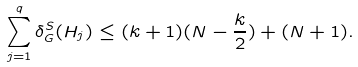<formula> <loc_0><loc_0><loc_500><loc_500>\sum _ { j = 1 } ^ { q } \delta ^ { S } _ { G } ( H _ { j } ) \leq ( k + 1 ) ( N - \frac { k } { 2 } ) + ( N + 1 ) .</formula> 